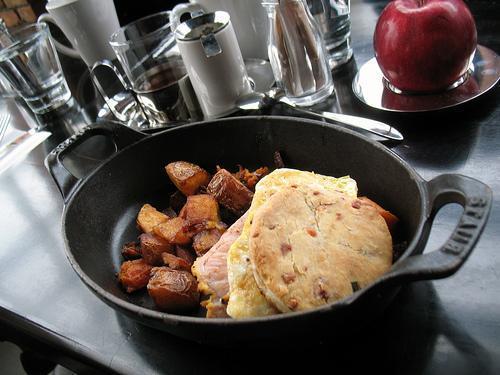How many apples are on the table?
Give a very brief answer. 1. 